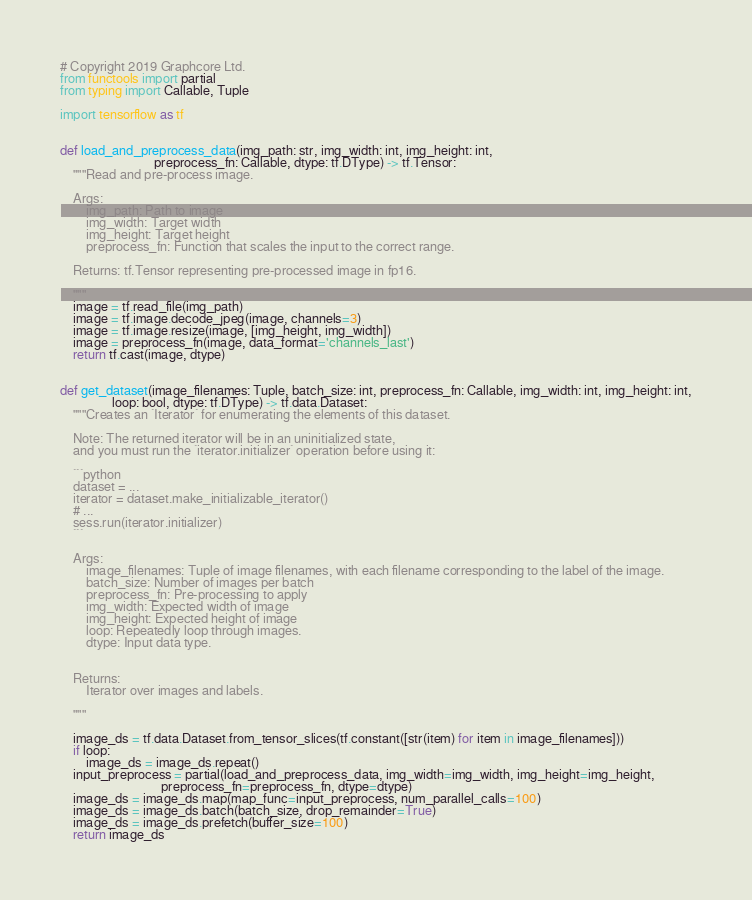<code> <loc_0><loc_0><loc_500><loc_500><_Python_># Copyright 2019 Graphcore Ltd.
from functools import partial
from typing import Callable, Tuple

import tensorflow as tf


def load_and_preprocess_data(img_path: str, img_width: int, img_height: int,
                             preprocess_fn: Callable, dtype: tf.DType) -> tf.Tensor:
    """Read and pre-process image.

    Args:
        img_path: Path to image
        img_width: Target width
        img_height: Target height
        preprocess_fn: Function that scales the input to the correct range.

    Returns: tf.Tensor representing pre-processed image in fp16.

    """
    image = tf.read_file(img_path)
    image = tf.image.decode_jpeg(image, channels=3)
    image = tf.image.resize(image, [img_height, img_width])
    image = preprocess_fn(image, data_format='channels_last')
    return tf.cast(image, dtype)


def get_dataset(image_filenames: Tuple, batch_size: int, preprocess_fn: Callable, img_width: int, img_height: int,
                loop: bool, dtype: tf.DType) -> tf.data.Dataset:
    """Creates an `Iterator` for enumerating the elements of this dataset.

    Note: The returned iterator will be in an uninitialized state,
    and you must run the `iterator.initializer` operation before using it:

    ```python
    dataset = ...
    iterator = dataset.make_initializable_iterator()
    # ...
    sess.run(iterator.initializer)
    ```

    Args:
        image_filenames: Tuple of image filenames, with each filename corresponding to the label of the image.
        batch_size: Number of images per batch
        preprocess_fn: Pre-processing to apply
        img_width: Expected width of image
        img_height: Expected height of image
        loop: Repeatedly loop through images.
        dtype: Input data type.


    Returns:
        Iterator over images and labels.

    """

    image_ds = tf.data.Dataset.from_tensor_slices(tf.constant([str(item) for item in image_filenames]))
    if loop:
        image_ds = image_ds.repeat()
    input_preprocess = partial(load_and_preprocess_data, img_width=img_width, img_height=img_height,
                               preprocess_fn=preprocess_fn, dtype=dtype)
    image_ds = image_ds.map(map_func=input_preprocess, num_parallel_calls=100)
    image_ds = image_ds.batch(batch_size, drop_remainder=True)
    image_ds = image_ds.prefetch(buffer_size=100)
    return image_ds
</code> 